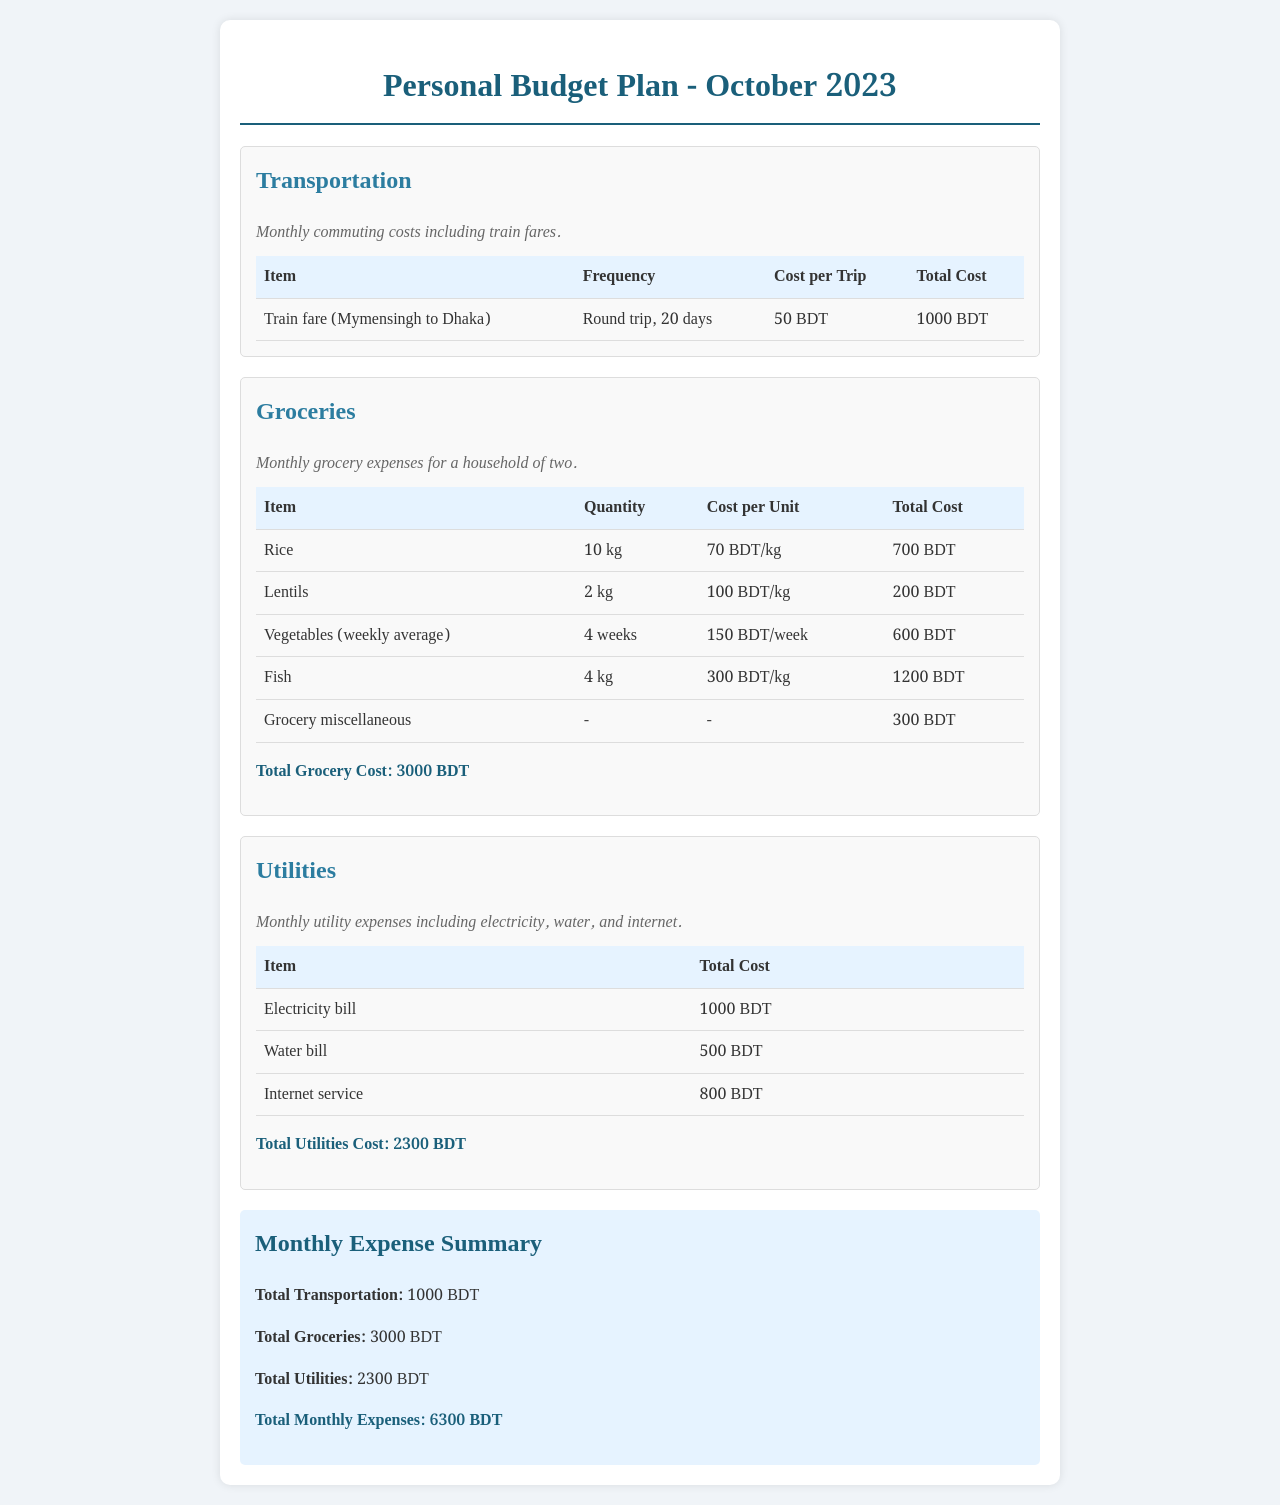What is the total cost for transportation? The total cost for transportation is given in the summary section of the document, which states the total transportation cost as 1000 BDT.
Answer: 1000 BDT How much does 1 kg of rice cost? The document states that rice costs 70 BDT/kg as listed in the groceries section.
Answer: 70 BDT/kg What is the total grocery cost? The total grocery cost is provided at the end of the groceries section, summing all the items, which amounts to 3000 BDT.
Answer: 3000 BDT How many days does the transportation cost cover? The transportation section specifies that the costs are for a round trip over 20 days.
Answer: 20 days What is the cost of the electricity bill? The utilities section lists the electricity bill cost as 1000 BDT.
Answer: 1000 BDT What is the total monthly expense? The total monthly expense is recorded in the summary section as the cumulative total of all categories, amounting to 6300 BDT.
Answer: 6300 BDT How many kilograms of fish are included in the grocery expenses? The groceries section indicates that 4 kg of fish is accounted for in the grocery costs.
Answer: 4 kg What is the cost of the internet service? The utilities section states that the internet service costs 800 BDT.
Answer: 800 BDT How often are vegetables purchased according to the grocery plan? The grocery table mentions that vegetables are purchased weekly, averaging over 4 weeks.
Answer: 4 weeks 